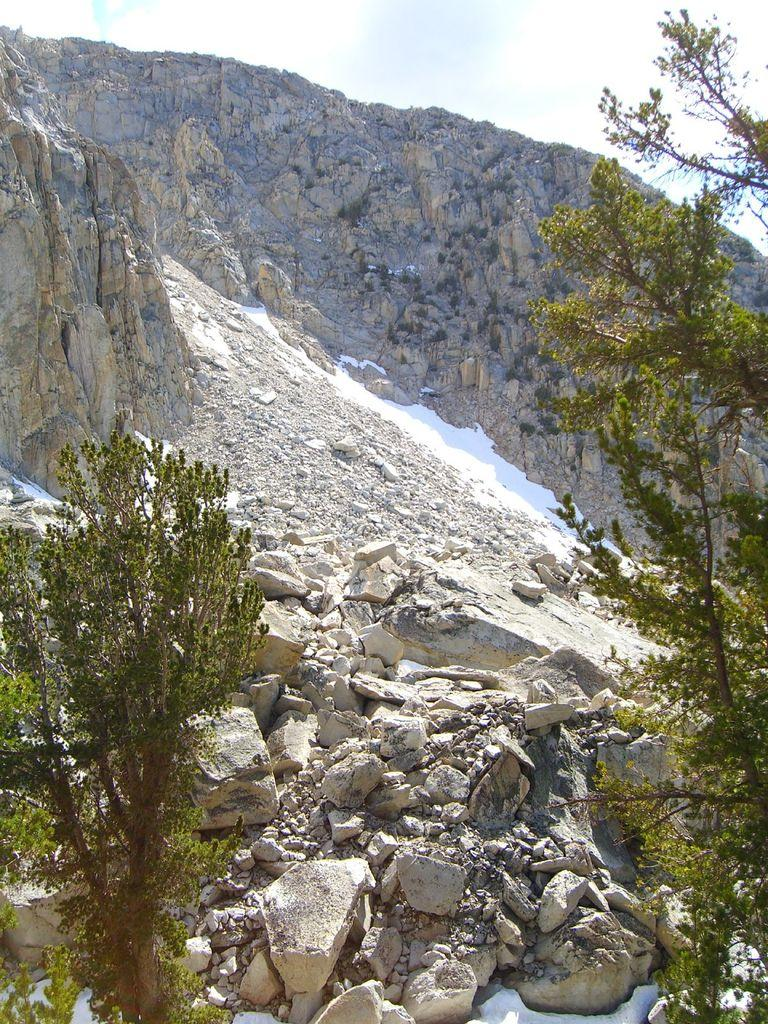What type of vegetation can be seen on the left side of the image? There are trees on the left side of the image. What type of vegetation can be seen on the right side of the image? There are trees on the right side of the image. What type of geological feature is visible in the image? There are rocks visible in the image. What type of large landform is present in the image? There is a mountain in the image. What part of the natural environment is visible in the image? The sky is visible in the image. Can you tell me how many eyes are visible on the mountain in the image? There are no eyes visible on the mountain in the image; it is a geological feature and not a living creature. What type of sail can be seen on the trees in the image? There are no sails present in the image; it features trees, rocks, a mountain, and the sky. 